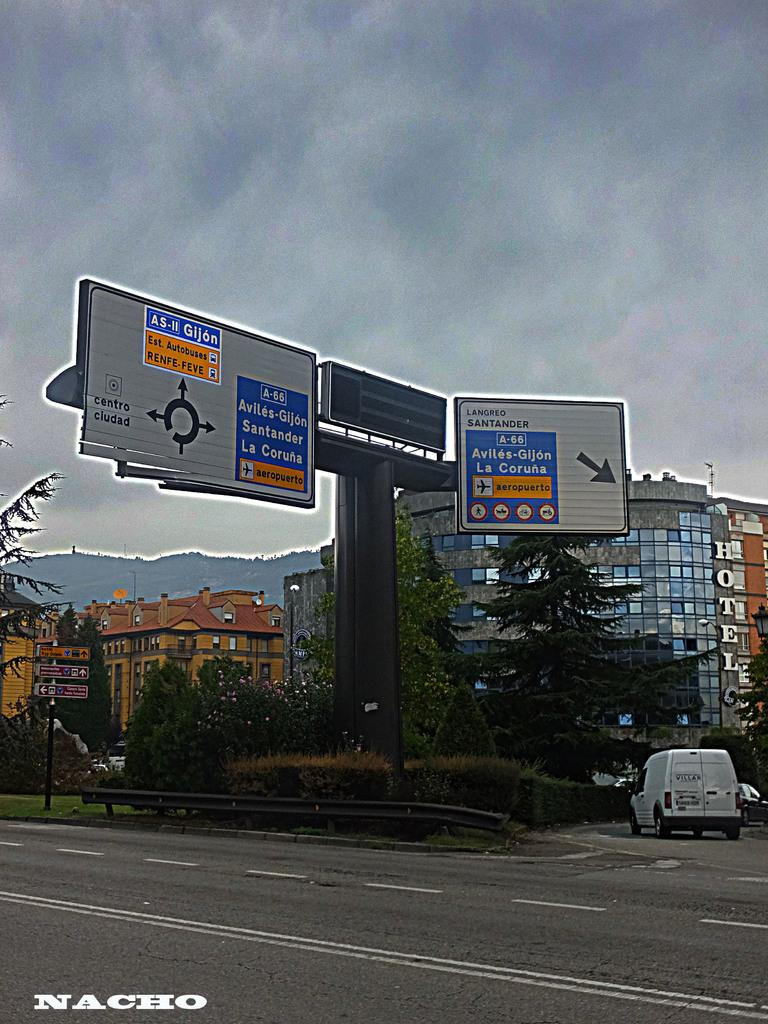<image>
Give a short and clear explanation of the subsequent image. signs to AS-II Gijon are on a roadway in front of buildings 